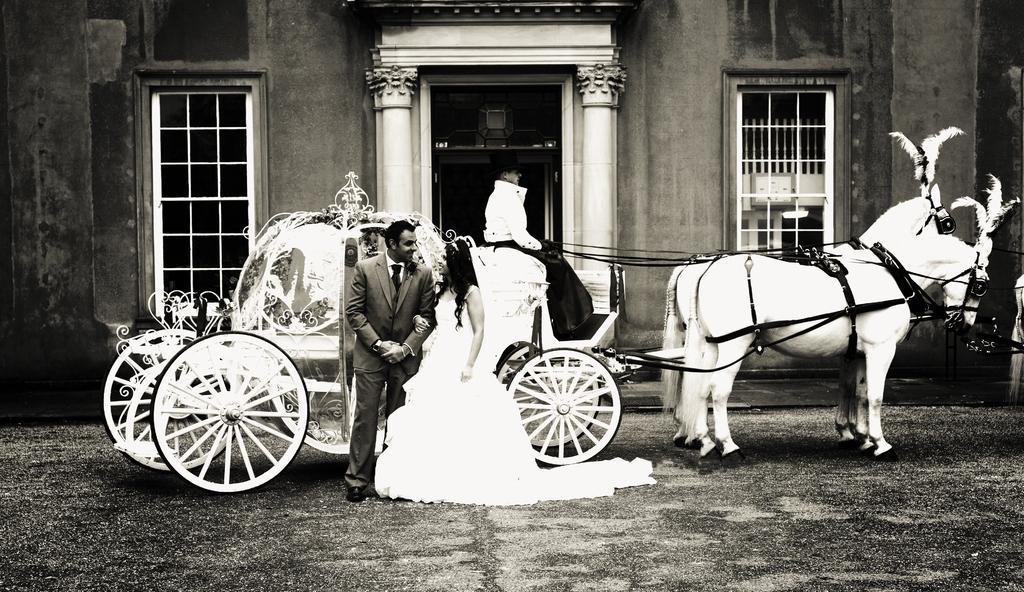In one or two sentences, can you explain what this image depicts? It looks like a black and white picture. We can see a man is sitting on the horse cart and in front of the cart there are two people standing on the path and behind the cart there is a building. 